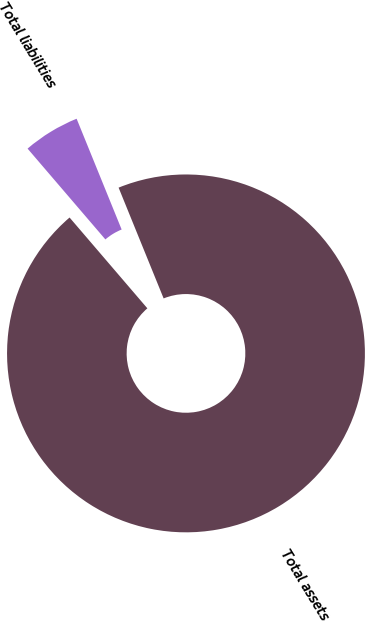Convert chart to OTSL. <chart><loc_0><loc_0><loc_500><loc_500><pie_chart><fcel>Total assets<fcel>Total liabilities<nl><fcel>94.87%<fcel>5.13%<nl></chart> 